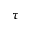<formula> <loc_0><loc_0><loc_500><loc_500>\tau</formula> 